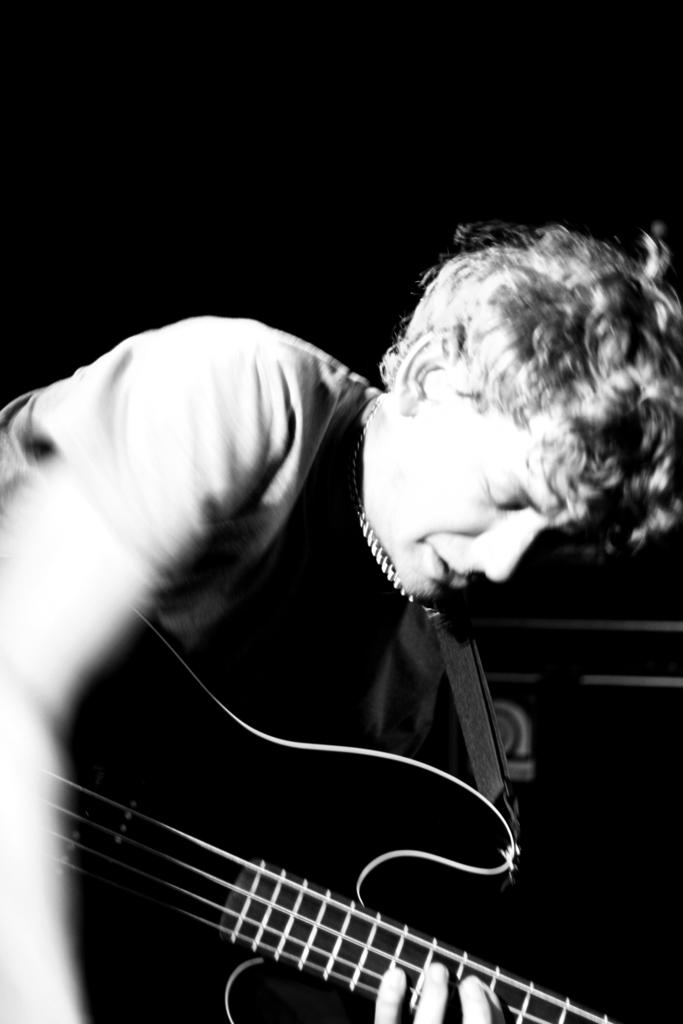Who is the main subject in the picture? There is a boy in the picture. What is the boy holding in the picture? The boy is holding a music instrument. Can you describe the music instrument in the picture? The music instrument is black in color. Can you see the dad playing with the moon in the picture? There is no dad or moon present in the picture; it only features a boy holding a black music instrument. 